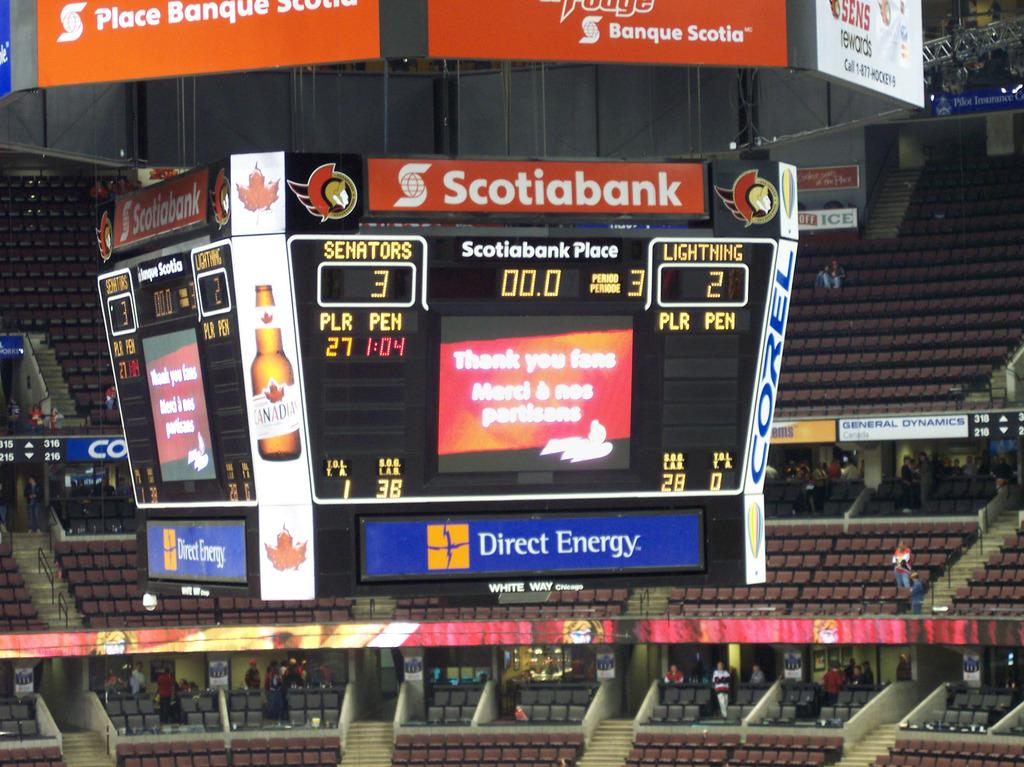Provide a one-sentence caption for the provided image. Scotiabank has a stadium named after it called Scotiabank Place. 